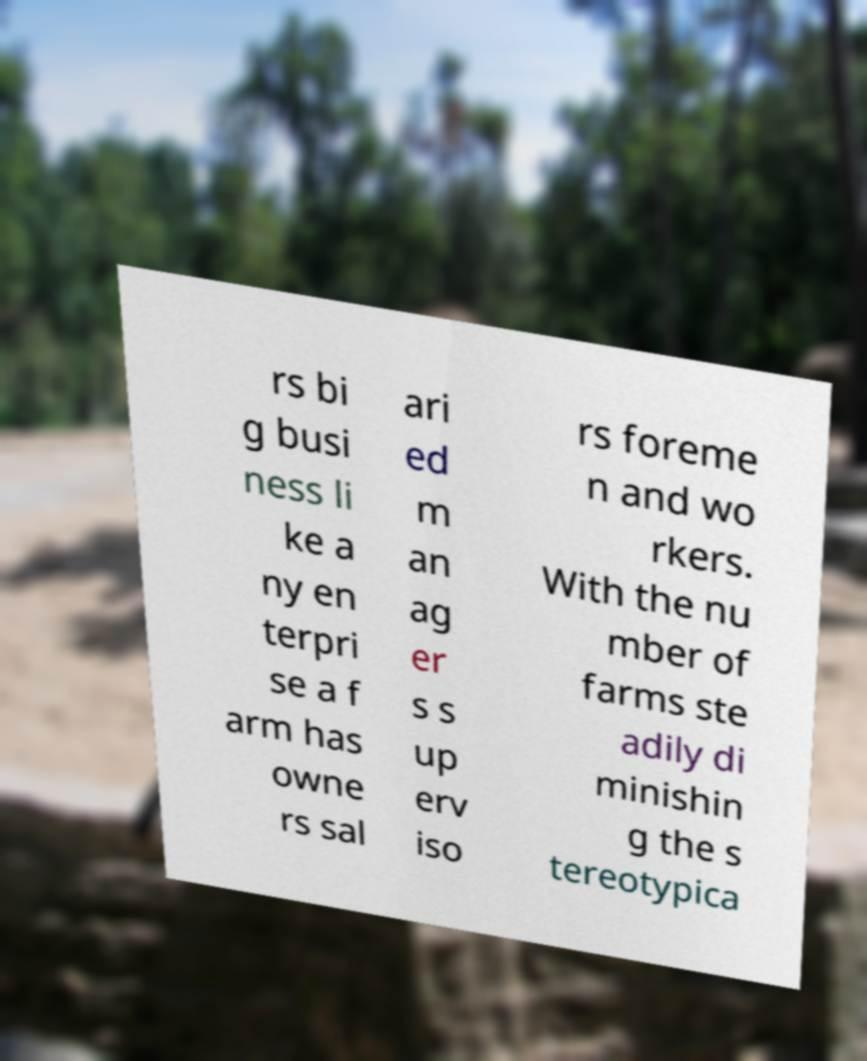Can you accurately transcribe the text from the provided image for me? rs bi g busi ness li ke a ny en terpri se a f arm has owne rs sal ari ed m an ag er s s up erv iso rs foreme n and wo rkers. With the nu mber of farms ste adily di minishin g the s tereotypica 